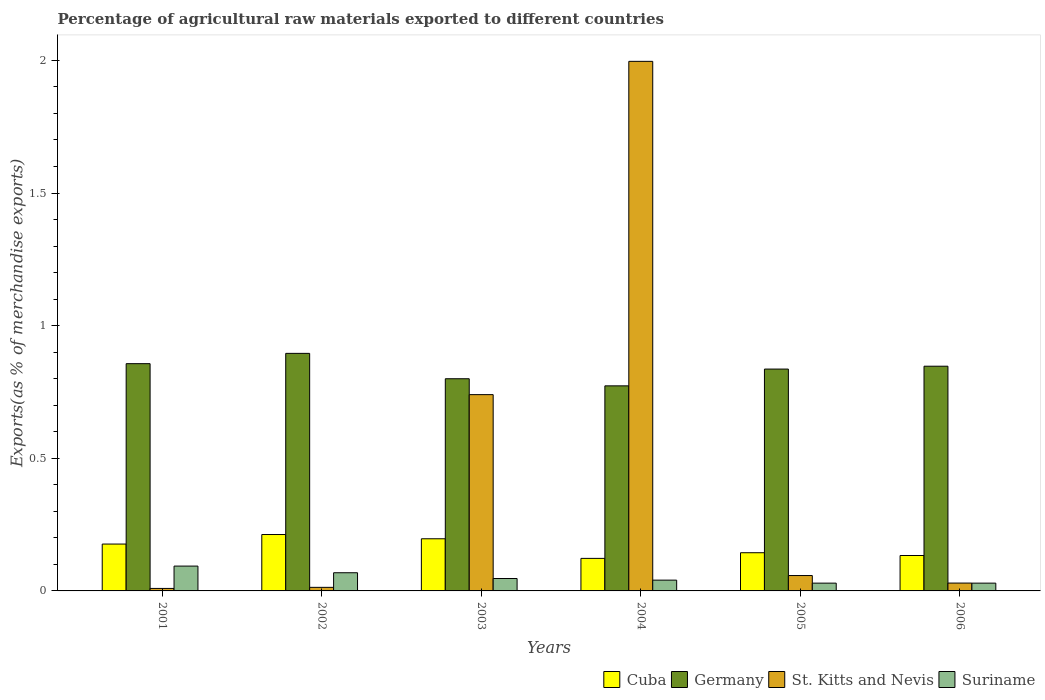How many different coloured bars are there?
Ensure brevity in your answer.  4. Are the number of bars per tick equal to the number of legend labels?
Provide a succinct answer. Yes. How many bars are there on the 5th tick from the left?
Make the answer very short. 4. How many bars are there on the 3rd tick from the right?
Offer a very short reply. 4. What is the label of the 4th group of bars from the left?
Provide a succinct answer. 2004. What is the percentage of exports to different countries in St. Kitts and Nevis in 2002?
Your answer should be compact. 0.01. Across all years, what is the maximum percentage of exports to different countries in Suriname?
Offer a very short reply. 0.09. Across all years, what is the minimum percentage of exports to different countries in Suriname?
Your answer should be compact. 0.03. In which year was the percentage of exports to different countries in Cuba minimum?
Make the answer very short. 2004. What is the total percentage of exports to different countries in St. Kitts and Nevis in the graph?
Offer a very short reply. 2.85. What is the difference between the percentage of exports to different countries in Germany in 2001 and that in 2004?
Provide a short and direct response. 0.08. What is the difference between the percentage of exports to different countries in Germany in 2003 and the percentage of exports to different countries in Suriname in 2001?
Your response must be concise. 0.71. What is the average percentage of exports to different countries in St. Kitts and Nevis per year?
Your answer should be compact. 0.47. In the year 2002, what is the difference between the percentage of exports to different countries in Germany and percentage of exports to different countries in Cuba?
Ensure brevity in your answer.  0.68. In how many years, is the percentage of exports to different countries in Suriname greater than 0.9 %?
Your response must be concise. 0. What is the ratio of the percentage of exports to different countries in Cuba in 2001 to that in 2003?
Ensure brevity in your answer.  0.9. What is the difference between the highest and the second highest percentage of exports to different countries in Suriname?
Your answer should be very brief. 0.03. What is the difference between the highest and the lowest percentage of exports to different countries in Cuba?
Make the answer very short. 0.09. Is the sum of the percentage of exports to different countries in Germany in 2003 and 2005 greater than the maximum percentage of exports to different countries in St. Kitts and Nevis across all years?
Keep it short and to the point. No. Is it the case that in every year, the sum of the percentage of exports to different countries in Germany and percentage of exports to different countries in Suriname is greater than the sum of percentage of exports to different countries in Cuba and percentage of exports to different countries in St. Kitts and Nevis?
Provide a short and direct response. Yes. What does the 4th bar from the left in 2004 represents?
Provide a succinct answer. Suriname. What does the 3rd bar from the right in 2005 represents?
Your response must be concise. Germany. Are the values on the major ticks of Y-axis written in scientific E-notation?
Your response must be concise. No. Does the graph contain any zero values?
Provide a succinct answer. No. Does the graph contain grids?
Offer a very short reply. No. Where does the legend appear in the graph?
Give a very brief answer. Bottom right. How are the legend labels stacked?
Give a very brief answer. Horizontal. What is the title of the graph?
Make the answer very short. Percentage of agricultural raw materials exported to different countries. Does "Tunisia" appear as one of the legend labels in the graph?
Keep it short and to the point. No. What is the label or title of the Y-axis?
Provide a succinct answer. Exports(as % of merchandise exports). What is the Exports(as % of merchandise exports) in Cuba in 2001?
Offer a very short reply. 0.18. What is the Exports(as % of merchandise exports) in Germany in 2001?
Provide a succinct answer. 0.86. What is the Exports(as % of merchandise exports) in St. Kitts and Nevis in 2001?
Your answer should be very brief. 0.01. What is the Exports(as % of merchandise exports) of Suriname in 2001?
Give a very brief answer. 0.09. What is the Exports(as % of merchandise exports) of Cuba in 2002?
Keep it short and to the point. 0.21. What is the Exports(as % of merchandise exports) of Germany in 2002?
Give a very brief answer. 0.9. What is the Exports(as % of merchandise exports) of St. Kitts and Nevis in 2002?
Make the answer very short. 0.01. What is the Exports(as % of merchandise exports) of Suriname in 2002?
Provide a short and direct response. 0.07. What is the Exports(as % of merchandise exports) of Cuba in 2003?
Your answer should be compact. 0.2. What is the Exports(as % of merchandise exports) of Germany in 2003?
Offer a terse response. 0.8. What is the Exports(as % of merchandise exports) in St. Kitts and Nevis in 2003?
Offer a very short reply. 0.74. What is the Exports(as % of merchandise exports) in Suriname in 2003?
Offer a terse response. 0.05. What is the Exports(as % of merchandise exports) in Cuba in 2004?
Offer a terse response. 0.12. What is the Exports(as % of merchandise exports) in Germany in 2004?
Your answer should be very brief. 0.77. What is the Exports(as % of merchandise exports) in St. Kitts and Nevis in 2004?
Give a very brief answer. 2. What is the Exports(as % of merchandise exports) of Suriname in 2004?
Your answer should be very brief. 0.04. What is the Exports(as % of merchandise exports) in Cuba in 2005?
Keep it short and to the point. 0.14. What is the Exports(as % of merchandise exports) in Germany in 2005?
Your response must be concise. 0.84. What is the Exports(as % of merchandise exports) of St. Kitts and Nevis in 2005?
Provide a short and direct response. 0.06. What is the Exports(as % of merchandise exports) in Suriname in 2005?
Ensure brevity in your answer.  0.03. What is the Exports(as % of merchandise exports) in Cuba in 2006?
Provide a short and direct response. 0.13. What is the Exports(as % of merchandise exports) of Germany in 2006?
Offer a terse response. 0.85. What is the Exports(as % of merchandise exports) in St. Kitts and Nevis in 2006?
Keep it short and to the point. 0.03. What is the Exports(as % of merchandise exports) of Suriname in 2006?
Offer a terse response. 0.03. Across all years, what is the maximum Exports(as % of merchandise exports) of Cuba?
Your response must be concise. 0.21. Across all years, what is the maximum Exports(as % of merchandise exports) in Germany?
Provide a short and direct response. 0.9. Across all years, what is the maximum Exports(as % of merchandise exports) of St. Kitts and Nevis?
Your answer should be compact. 2. Across all years, what is the maximum Exports(as % of merchandise exports) of Suriname?
Provide a short and direct response. 0.09. Across all years, what is the minimum Exports(as % of merchandise exports) of Cuba?
Make the answer very short. 0.12. Across all years, what is the minimum Exports(as % of merchandise exports) in Germany?
Make the answer very short. 0.77. Across all years, what is the minimum Exports(as % of merchandise exports) of St. Kitts and Nevis?
Ensure brevity in your answer.  0.01. Across all years, what is the minimum Exports(as % of merchandise exports) in Suriname?
Provide a short and direct response. 0.03. What is the total Exports(as % of merchandise exports) of Cuba in the graph?
Keep it short and to the point. 0.99. What is the total Exports(as % of merchandise exports) of Germany in the graph?
Give a very brief answer. 5.01. What is the total Exports(as % of merchandise exports) of St. Kitts and Nevis in the graph?
Your answer should be very brief. 2.85. What is the total Exports(as % of merchandise exports) of Suriname in the graph?
Provide a succinct answer. 0.31. What is the difference between the Exports(as % of merchandise exports) of Cuba in 2001 and that in 2002?
Provide a short and direct response. -0.04. What is the difference between the Exports(as % of merchandise exports) of Germany in 2001 and that in 2002?
Your answer should be compact. -0.04. What is the difference between the Exports(as % of merchandise exports) in St. Kitts and Nevis in 2001 and that in 2002?
Ensure brevity in your answer.  -0. What is the difference between the Exports(as % of merchandise exports) in Suriname in 2001 and that in 2002?
Provide a short and direct response. 0.03. What is the difference between the Exports(as % of merchandise exports) of Cuba in 2001 and that in 2003?
Give a very brief answer. -0.02. What is the difference between the Exports(as % of merchandise exports) in Germany in 2001 and that in 2003?
Provide a short and direct response. 0.06. What is the difference between the Exports(as % of merchandise exports) in St. Kitts and Nevis in 2001 and that in 2003?
Offer a terse response. -0.73. What is the difference between the Exports(as % of merchandise exports) in Suriname in 2001 and that in 2003?
Ensure brevity in your answer.  0.05. What is the difference between the Exports(as % of merchandise exports) in Cuba in 2001 and that in 2004?
Your response must be concise. 0.05. What is the difference between the Exports(as % of merchandise exports) of Germany in 2001 and that in 2004?
Give a very brief answer. 0.08. What is the difference between the Exports(as % of merchandise exports) of St. Kitts and Nevis in 2001 and that in 2004?
Offer a terse response. -1.99. What is the difference between the Exports(as % of merchandise exports) of Suriname in 2001 and that in 2004?
Ensure brevity in your answer.  0.05. What is the difference between the Exports(as % of merchandise exports) in Cuba in 2001 and that in 2005?
Your answer should be compact. 0.03. What is the difference between the Exports(as % of merchandise exports) of Germany in 2001 and that in 2005?
Your response must be concise. 0.02. What is the difference between the Exports(as % of merchandise exports) in St. Kitts and Nevis in 2001 and that in 2005?
Offer a very short reply. -0.05. What is the difference between the Exports(as % of merchandise exports) in Suriname in 2001 and that in 2005?
Your response must be concise. 0.06. What is the difference between the Exports(as % of merchandise exports) in Cuba in 2001 and that in 2006?
Give a very brief answer. 0.04. What is the difference between the Exports(as % of merchandise exports) in Germany in 2001 and that in 2006?
Provide a short and direct response. 0.01. What is the difference between the Exports(as % of merchandise exports) in St. Kitts and Nevis in 2001 and that in 2006?
Your answer should be very brief. -0.02. What is the difference between the Exports(as % of merchandise exports) in Suriname in 2001 and that in 2006?
Provide a succinct answer. 0.06. What is the difference between the Exports(as % of merchandise exports) of Cuba in 2002 and that in 2003?
Provide a succinct answer. 0.02. What is the difference between the Exports(as % of merchandise exports) in Germany in 2002 and that in 2003?
Ensure brevity in your answer.  0.1. What is the difference between the Exports(as % of merchandise exports) in St. Kitts and Nevis in 2002 and that in 2003?
Your answer should be very brief. -0.73. What is the difference between the Exports(as % of merchandise exports) of Suriname in 2002 and that in 2003?
Keep it short and to the point. 0.02. What is the difference between the Exports(as % of merchandise exports) of Cuba in 2002 and that in 2004?
Keep it short and to the point. 0.09. What is the difference between the Exports(as % of merchandise exports) of Germany in 2002 and that in 2004?
Keep it short and to the point. 0.12. What is the difference between the Exports(as % of merchandise exports) in St. Kitts and Nevis in 2002 and that in 2004?
Offer a very short reply. -1.98. What is the difference between the Exports(as % of merchandise exports) of Suriname in 2002 and that in 2004?
Your response must be concise. 0.03. What is the difference between the Exports(as % of merchandise exports) of Cuba in 2002 and that in 2005?
Ensure brevity in your answer.  0.07. What is the difference between the Exports(as % of merchandise exports) of Germany in 2002 and that in 2005?
Offer a very short reply. 0.06. What is the difference between the Exports(as % of merchandise exports) of St. Kitts and Nevis in 2002 and that in 2005?
Your answer should be very brief. -0.04. What is the difference between the Exports(as % of merchandise exports) of Suriname in 2002 and that in 2005?
Offer a very short reply. 0.04. What is the difference between the Exports(as % of merchandise exports) in Cuba in 2002 and that in 2006?
Offer a very short reply. 0.08. What is the difference between the Exports(as % of merchandise exports) of Germany in 2002 and that in 2006?
Make the answer very short. 0.05. What is the difference between the Exports(as % of merchandise exports) of St. Kitts and Nevis in 2002 and that in 2006?
Provide a short and direct response. -0.02. What is the difference between the Exports(as % of merchandise exports) of Suriname in 2002 and that in 2006?
Provide a short and direct response. 0.04. What is the difference between the Exports(as % of merchandise exports) in Cuba in 2003 and that in 2004?
Provide a short and direct response. 0.07. What is the difference between the Exports(as % of merchandise exports) in Germany in 2003 and that in 2004?
Give a very brief answer. 0.03. What is the difference between the Exports(as % of merchandise exports) in St. Kitts and Nevis in 2003 and that in 2004?
Give a very brief answer. -1.26. What is the difference between the Exports(as % of merchandise exports) in Suriname in 2003 and that in 2004?
Keep it short and to the point. 0.01. What is the difference between the Exports(as % of merchandise exports) in Cuba in 2003 and that in 2005?
Give a very brief answer. 0.05. What is the difference between the Exports(as % of merchandise exports) of Germany in 2003 and that in 2005?
Give a very brief answer. -0.04. What is the difference between the Exports(as % of merchandise exports) in St. Kitts and Nevis in 2003 and that in 2005?
Keep it short and to the point. 0.68. What is the difference between the Exports(as % of merchandise exports) of Suriname in 2003 and that in 2005?
Offer a terse response. 0.02. What is the difference between the Exports(as % of merchandise exports) in Cuba in 2003 and that in 2006?
Make the answer very short. 0.06. What is the difference between the Exports(as % of merchandise exports) in Germany in 2003 and that in 2006?
Your answer should be compact. -0.05. What is the difference between the Exports(as % of merchandise exports) of St. Kitts and Nevis in 2003 and that in 2006?
Provide a succinct answer. 0.71. What is the difference between the Exports(as % of merchandise exports) of Suriname in 2003 and that in 2006?
Offer a terse response. 0.02. What is the difference between the Exports(as % of merchandise exports) in Cuba in 2004 and that in 2005?
Your response must be concise. -0.02. What is the difference between the Exports(as % of merchandise exports) of Germany in 2004 and that in 2005?
Your response must be concise. -0.06. What is the difference between the Exports(as % of merchandise exports) of St. Kitts and Nevis in 2004 and that in 2005?
Offer a very short reply. 1.94. What is the difference between the Exports(as % of merchandise exports) in Suriname in 2004 and that in 2005?
Make the answer very short. 0.01. What is the difference between the Exports(as % of merchandise exports) in Cuba in 2004 and that in 2006?
Provide a short and direct response. -0.01. What is the difference between the Exports(as % of merchandise exports) of Germany in 2004 and that in 2006?
Ensure brevity in your answer.  -0.07. What is the difference between the Exports(as % of merchandise exports) in St. Kitts and Nevis in 2004 and that in 2006?
Make the answer very short. 1.97. What is the difference between the Exports(as % of merchandise exports) of Suriname in 2004 and that in 2006?
Give a very brief answer. 0.01. What is the difference between the Exports(as % of merchandise exports) in Cuba in 2005 and that in 2006?
Your answer should be very brief. 0.01. What is the difference between the Exports(as % of merchandise exports) of Germany in 2005 and that in 2006?
Your response must be concise. -0.01. What is the difference between the Exports(as % of merchandise exports) in St. Kitts and Nevis in 2005 and that in 2006?
Make the answer very short. 0.03. What is the difference between the Exports(as % of merchandise exports) of Suriname in 2005 and that in 2006?
Your answer should be very brief. 0. What is the difference between the Exports(as % of merchandise exports) in Cuba in 2001 and the Exports(as % of merchandise exports) in Germany in 2002?
Provide a succinct answer. -0.72. What is the difference between the Exports(as % of merchandise exports) of Cuba in 2001 and the Exports(as % of merchandise exports) of St. Kitts and Nevis in 2002?
Give a very brief answer. 0.16. What is the difference between the Exports(as % of merchandise exports) of Cuba in 2001 and the Exports(as % of merchandise exports) of Suriname in 2002?
Provide a succinct answer. 0.11. What is the difference between the Exports(as % of merchandise exports) of Germany in 2001 and the Exports(as % of merchandise exports) of St. Kitts and Nevis in 2002?
Your answer should be compact. 0.84. What is the difference between the Exports(as % of merchandise exports) in Germany in 2001 and the Exports(as % of merchandise exports) in Suriname in 2002?
Offer a very short reply. 0.79. What is the difference between the Exports(as % of merchandise exports) in St. Kitts and Nevis in 2001 and the Exports(as % of merchandise exports) in Suriname in 2002?
Your answer should be compact. -0.06. What is the difference between the Exports(as % of merchandise exports) in Cuba in 2001 and the Exports(as % of merchandise exports) in Germany in 2003?
Give a very brief answer. -0.62. What is the difference between the Exports(as % of merchandise exports) in Cuba in 2001 and the Exports(as % of merchandise exports) in St. Kitts and Nevis in 2003?
Provide a succinct answer. -0.56. What is the difference between the Exports(as % of merchandise exports) in Cuba in 2001 and the Exports(as % of merchandise exports) in Suriname in 2003?
Provide a succinct answer. 0.13. What is the difference between the Exports(as % of merchandise exports) in Germany in 2001 and the Exports(as % of merchandise exports) in St. Kitts and Nevis in 2003?
Your answer should be compact. 0.12. What is the difference between the Exports(as % of merchandise exports) in Germany in 2001 and the Exports(as % of merchandise exports) in Suriname in 2003?
Your answer should be compact. 0.81. What is the difference between the Exports(as % of merchandise exports) of St. Kitts and Nevis in 2001 and the Exports(as % of merchandise exports) of Suriname in 2003?
Offer a terse response. -0.04. What is the difference between the Exports(as % of merchandise exports) in Cuba in 2001 and the Exports(as % of merchandise exports) in Germany in 2004?
Your answer should be very brief. -0.6. What is the difference between the Exports(as % of merchandise exports) in Cuba in 2001 and the Exports(as % of merchandise exports) in St. Kitts and Nevis in 2004?
Your answer should be compact. -1.82. What is the difference between the Exports(as % of merchandise exports) of Cuba in 2001 and the Exports(as % of merchandise exports) of Suriname in 2004?
Your answer should be compact. 0.14. What is the difference between the Exports(as % of merchandise exports) of Germany in 2001 and the Exports(as % of merchandise exports) of St. Kitts and Nevis in 2004?
Make the answer very short. -1.14. What is the difference between the Exports(as % of merchandise exports) of Germany in 2001 and the Exports(as % of merchandise exports) of Suriname in 2004?
Your answer should be compact. 0.82. What is the difference between the Exports(as % of merchandise exports) in St. Kitts and Nevis in 2001 and the Exports(as % of merchandise exports) in Suriname in 2004?
Provide a short and direct response. -0.03. What is the difference between the Exports(as % of merchandise exports) in Cuba in 2001 and the Exports(as % of merchandise exports) in Germany in 2005?
Provide a short and direct response. -0.66. What is the difference between the Exports(as % of merchandise exports) of Cuba in 2001 and the Exports(as % of merchandise exports) of St. Kitts and Nevis in 2005?
Keep it short and to the point. 0.12. What is the difference between the Exports(as % of merchandise exports) in Cuba in 2001 and the Exports(as % of merchandise exports) in Suriname in 2005?
Offer a very short reply. 0.15. What is the difference between the Exports(as % of merchandise exports) in Germany in 2001 and the Exports(as % of merchandise exports) in St. Kitts and Nevis in 2005?
Offer a very short reply. 0.8. What is the difference between the Exports(as % of merchandise exports) of Germany in 2001 and the Exports(as % of merchandise exports) of Suriname in 2005?
Your response must be concise. 0.83. What is the difference between the Exports(as % of merchandise exports) of St. Kitts and Nevis in 2001 and the Exports(as % of merchandise exports) of Suriname in 2005?
Provide a short and direct response. -0.02. What is the difference between the Exports(as % of merchandise exports) in Cuba in 2001 and the Exports(as % of merchandise exports) in Germany in 2006?
Offer a terse response. -0.67. What is the difference between the Exports(as % of merchandise exports) of Cuba in 2001 and the Exports(as % of merchandise exports) of St. Kitts and Nevis in 2006?
Your answer should be compact. 0.15. What is the difference between the Exports(as % of merchandise exports) of Cuba in 2001 and the Exports(as % of merchandise exports) of Suriname in 2006?
Your response must be concise. 0.15. What is the difference between the Exports(as % of merchandise exports) in Germany in 2001 and the Exports(as % of merchandise exports) in St. Kitts and Nevis in 2006?
Offer a very short reply. 0.83. What is the difference between the Exports(as % of merchandise exports) in Germany in 2001 and the Exports(as % of merchandise exports) in Suriname in 2006?
Give a very brief answer. 0.83. What is the difference between the Exports(as % of merchandise exports) of St. Kitts and Nevis in 2001 and the Exports(as % of merchandise exports) of Suriname in 2006?
Keep it short and to the point. -0.02. What is the difference between the Exports(as % of merchandise exports) of Cuba in 2002 and the Exports(as % of merchandise exports) of Germany in 2003?
Offer a terse response. -0.59. What is the difference between the Exports(as % of merchandise exports) of Cuba in 2002 and the Exports(as % of merchandise exports) of St. Kitts and Nevis in 2003?
Provide a succinct answer. -0.53. What is the difference between the Exports(as % of merchandise exports) of Cuba in 2002 and the Exports(as % of merchandise exports) of Suriname in 2003?
Keep it short and to the point. 0.17. What is the difference between the Exports(as % of merchandise exports) in Germany in 2002 and the Exports(as % of merchandise exports) in St. Kitts and Nevis in 2003?
Offer a terse response. 0.16. What is the difference between the Exports(as % of merchandise exports) in Germany in 2002 and the Exports(as % of merchandise exports) in Suriname in 2003?
Keep it short and to the point. 0.85. What is the difference between the Exports(as % of merchandise exports) of St. Kitts and Nevis in 2002 and the Exports(as % of merchandise exports) of Suriname in 2003?
Your answer should be compact. -0.03. What is the difference between the Exports(as % of merchandise exports) in Cuba in 2002 and the Exports(as % of merchandise exports) in Germany in 2004?
Offer a very short reply. -0.56. What is the difference between the Exports(as % of merchandise exports) in Cuba in 2002 and the Exports(as % of merchandise exports) in St. Kitts and Nevis in 2004?
Ensure brevity in your answer.  -1.78. What is the difference between the Exports(as % of merchandise exports) in Cuba in 2002 and the Exports(as % of merchandise exports) in Suriname in 2004?
Provide a succinct answer. 0.17. What is the difference between the Exports(as % of merchandise exports) of Germany in 2002 and the Exports(as % of merchandise exports) of St. Kitts and Nevis in 2004?
Provide a short and direct response. -1.1. What is the difference between the Exports(as % of merchandise exports) of Germany in 2002 and the Exports(as % of merchandise exports) of Suriname in 2004?
Offer a terse response. 0.85. What is the difference between the Exports(as % of merchandise exports) in St. Kitts and Nevis in 2002 and the Exports(as % of merchandise exports) in Suriname in 2004?
Offer a terse response. -0.03. What is the difference between the Exports(as % of merchandise exports) in Cuba in 2002 and the Exports(as % of merchandise exports) in Germany in 2005?
Your answer should be compact. -0.62. What is the difference between the Exports(as % of merchandise exports) in Cuba in 2002 and the Exports(as % of merchandise exports) in St. Kitts and Nevis in 2005?
Offer a terse response. 0.15. What is the difference between the Exports(as % of merchandise exports) of Cuba in 2002 and the Exports(as % of merchandise exports) of Suriname in 2005?
Ensure brevity in your answer.  0.18. What is the difference between the Exports(as % of merchandise exports) in Germany in 2002 and the Exports(as % of merchandise exports) in St. Kitts and Nevis in 2005?
Your response must be concise. 0.84. What is the difference between the Exports(as % of merchandise exports) of Germany in 2002 and the Exports(as % of merchandise exports) of Suriname in 2005?
Your answer should be compact. 0.87. What is the difference between the Exports(as % of merchandise exports) of St. Kitts and Nevis in 2002 and the Exports(as % of merchandise exports) of Suriname in 2005?
Make the answer very short. -0.02. What is the difference between the Exports(as % of merchandise exports) of Cuba in 2002 and the Exports(as % of merchandise exports) of Germany in 2006?
Offer a very short reply. -0.63. What is the difference between the Exports(as % of merchandise exports) of Cuba in 2002 and the Exports(as % of merchandise exports) of St. Kitts and Nevis in 2006?
Provide a succinct answer. 0.18. What is the difference between the Exports(as % of merchandise exports) in Cuba in 2002 and the Exports(as % of merchandise exports) in Suriname in 2006?
Provide a short and direct response. 0.18. What is the difference between the Exports(as % of merchandise exports) of Germany in 2002 and the Exports(as % of merchandise exports) of St. Kitts and Nevis in 2006?
Keep it short and to the point. 0.87. What is the difference between the Exports(as % of merchandise exports) of Germany in 2002 and the Exports(as % of merchandise exports) of Suriname in 2006?
Provide a short and direct response. 0.87. What is the difference between the Exports(as % of merchandise exports) in St. Kitts and Nevis in 2002 and the Exports(as % of merchandise exports) in Suriname in 2006?
Offer a terse response. -0.02. What is the difference between the Exports(as % of merchandise exports) of Cuba in 2003 and the Exports(as % of merchandise exports) of Germany in 2004?
Your answer should be compact. -0.58. What is the difference between the Exports(as % of merchandise exports) of Cuba in 2003 and the Exports(as % of merchandise exports) of St. Kitts and Nevis in 2004?
Provide a short and direct response. -1.8. What is the difference between the Exports(as % of merchandise exports) of Cuba in 2003 and the Exports(as % of merchandise exports) of Suriname in 2004?
Your response must be concise. 0.16. What is the difference between the Exports(as % of merchandise exports) in Germany in 2003 and the Exports(as % of merchandise exports) in St. Kitts and Nevis in 2004?
Offer a very short reply. -1.2. What is the difference between the Exports(as % of merchandise exports) of Germany in 2003 and the Exports(as % of merchandise exports) of Suriname in 2004?
Your answer should be compact. 0.76. What is the difference between the Exports(as % of merchandise exports) of St. Kitts and Nevis in 2003 and the Exports(as % of merchandise exports) of Suriname in 2004?
Your answer should be compact. 0.7. What is the difference between the Exports(as % of merchandise exports) of Cuba in 2003 and the Exports(as % of merchandise exports) of Germany in 2005?
Provide a short and direct response. -0.64. What is the difference between the Exports(as % of merchandise exports) of Cuba in 2003 and the Exports(as % of merchandise exports) of St. Kitts and Nevis in 2005?
Your response must be concise. 0.14. What is the difference between the Exports(as % of merchandise exports) of Cuba in 2003 and the Exports(as % of merchandise exports) of Suriname in 2005?
Make the answer very short. 0.17. What is the difference between the Exports(as % of merchandise exports) in Germany in 2003 and the Exports(as % of merchandise exports) in St. Kitts and Nevis in 2005?
Provide a short and direct response. 0.74. What is the difference between the Exports(as % of merchandise exports) in Germany in 2003 and the Exports(as % of merchandise exports) in Suriname in 2005?
Keep it short and to the point. 0.77. What is the difference between the Exports(as % of merchandise exports) of St. Kitts and Nevis in 2003 and the Exports(as % of merchandise exports) of Suriname in 2005?
Your response must be concise. 0.71. What is the difference between the Exports(as % of merchandise exports) in Cuba in 2003 and the Exports(as % of merchandise exports) in Germany in 2006?
Ensure brevity in your answer.  -0.65. What is the difference between the Exports(as % of merchandise exports) in Cuba in 2003 and the Exports(as % of merchandise exports) in St. Kitts and Nevis in 2006?
Ensure brevity in your answer.  0.17. What is the difference between the Exports(as % of merchandise exports) of Cuba in 2003 and the Exports(as % of merchandise exports) of Suriname in 2006?
Your response must be concise. 0.17. What is the difference between the Exports(as % of merchandise exports) of Germany in 2003 and the Exports(as % of merchandise exports) of St. Kitts and Nevis in 2006?
Offer a terse response. 0.77. What is the difference between the Exports(as % of merchandise exports) in Germany in 2003 and the Exports(as % of merchandise exports) in Suriname in 2006?
Your response must be concise. 0.77. What is the difference between the Exports(as % of merchandise exports) in St. Kitts and Nevis in 2003 and the Exports(as % of merchandise exports) in Suriname in 2006?
Offer a very short reply. 0.71. What is the difference between the Exports(as % of merchandise exports) of Cuba in 2004 and the Exports(as % of merchandise exports) of Germany in 2005?
Offer a very short reply. -0.71. What is the difference between the Exports(as % of merchandise exports) of Cuba in 2004 and the Exports(as % of merchandise exports) of St. Kitts and Nevis in 2005?
Your response must be concise. 0.06. What is the difference between the Exports(as % of merchandise exports) in Cuba in 2004 and the Exports(as % of merchandise exports) in Suriname in 2005?
Give a very brief answer. 0.09. What is the difference between the Exports(as % of merchandise exports) of Germany in 2004 and the Exports(as % of merchandise exports) of St. Kitts and Nevis in 2005?
Keep it short and to the point. 0.72. What is the difference between the Exports(as % of merchandise exports) in Germany in 2004 and the Exports(as % of merchandise exports) in Suriname in 2005?
Offer a very short reply. 0.74. What is the difference between the Exports(as % of merchandise exports) of St. Kitts and Nevis in 2004 and the Exports(as % of merchandise exports) of Suriname in 2005?
Offer a very short reply. 1.97. What is the difference between the Exports(as % of merchandise exports) of Cuba in 2004 and the Exports(as % of merchandise exports) of Germany in 2006?
Offer a terse response. -0.72. What is the difference between the Exports(as % of merchandise exports) in Cuba in 2004 and the Exports(as % of merchandise exports) in St. Kitts and Nevis in 2006?
Provide a succinct answer. 0.09. What is the difference between the Exports(as % of merchandise exports) in Cuba in 2004 and the Exports(as % of merchandise exports) in Suriname in 2006?
Ensure brevity in your answer.  0.09. What is the difference between the Exports(as % of merchandise exports) in Germany in 2004 and the Exports(as % of merchandise exports) in St. Kitts and Nevis in 2006?
Offer a terse response. 0.74. What is the difference between the Exports(as % of merchandise exports) in Germany in 2004 and the Exports(as % of merchandise exports) in Suriname in 2006?
Give a very brief answer. 0.74. What is the difference between the Exports(as % of merchandise exports) of St. Kitts and Nevis in 2004 and the Exports(as % of merchandise exports) of Suriname in 2006?
Your response must be concise. 1.97. What is the difference between the Exports(as % of merchandise exports) in Cuba in 2005 and the Exports(as % of merchandise exports) in Germany in 2006?
Your answer should be compact. -0.7. What is the difference between the Exports(as % of merchandise exports) in Cuba in 2005 and the Exports(as % of merchandise exports) in St. Kitts and Nevis in 2006?
Make the answer very short. 0.11. What is the difference between the Exports(as % of merchandise exports) in Cuba in 2005 and the Exports(as % of merchandise exports) in Suriname in 2006?
Your answer should be compact. 0.11. What is the difference between the Exports(as % of merchandise exports) of Germany in 2005 and the Exports(as % of merchandise exports) of St. Kitts and Nevis in 2006?
Keep it short and to the point. 0.81. What is the difference between the Exports(as % of merchandise exports) of Germany in 2005 and the Exports(as % of merchandise exports) of Suriname in 2006?
Make the answer very short. 0.81. What is the difference between the Exports(as % of merchandise exports) in St. Kitts and Nevis in 2005 and the Exports(as % of merchandise exports) in Suriname in 2006?
Offer a very short reply. 0.03. What is the average Exports(as % of merchandise exports) in Cuba per year?
Your response must be concise. 0.16. What is the average Exports(as % of merchandise exports) of Germany per year?
Give a very brief answer. 0.83. What is the average Exports(as % of merchandise exports) of St. Kitts and Nevis per year?
Give a very brief answer. 0.47. What is the average Exports(as % of merchandise exports) of Suriname per year?
Offer a terse response. 0.05. In the year 2001, what is the difference between the Exports(as % of merchandise exports) in Cuba and Exports(as % of merchandise exports) in Germany?
Your answer should be compact. -0.68. In the year 2001, what is the difference between the Exports(as % of merchandise exports) in Cuba and Exports(as % of merchandise exports) in St. Kitts and Nevis?
Offer a very short reply. 0.17. In the year 2001, what is the difference between the Exports(as % of merchandise exports) of Cuba and Exports(as % of merchandise exports) of Suriname?
Make the answer very short. 0.08. In the year 2001, what is the difference between the Exports(as % of merchandise exports) of Germany and Exports(as % of merchandise exports) of St. Kitts and Nevis?
Offer a very short reply. 0.85. In the year 2001, what is the difference between the Exports(as % of merchandise exports) of Germany and Exports(as % of merchandise exports) of Suriname?
Ensure brevity in your answer.  0.76. In the year 2001, what is the difference between the Exports(as % of merchandise exports) of St. Kitts and Nevis and Exports(as % of merchandise exports) of Suriname?
Your answer should be compact. -0.08. In the year 2002, what is the difference between the Exports(as % of merchandise exports) in Cuba and Exports(as % of merchandise exports) in Germany?
Provide a short and direct response. -0.68. In the year 2002, what is the difference between the Exports(as % of merchandise exports) of Cuba and Exports(as % of merchandise exports) of St. Kitts and Nevis?
Offer a terse response. 0.2. In the year 2002, what is the difference between the Exports(as % of merchandise exports) in Cuba and Exports(as % of merchandise exports) in Suriname?
Keep it short and to the point. 0.14. In the year 2002, what is the difference between the Exports(as % of merchandise exports) in Germany and Exports(as % of merchandise exports) in St. Kitts and Nevis?
Ensure brevity in your answer.  0.88. In the year 2002, what is the difference between the Exports(as % of merchandise exports) in Germany and Exports(as % of merchandise exports) in Suriname?
Your answer should be very brief. 0.83. In the year 2002, what is the difference between the Exports(as % of merchandise exports) in St. Kitts and Nevis and Exports(as % of merchandise exports) in Suriname?
Provide a succinct answer. -0.06. In the year 2003, what is the difference between the Exports(as % of merchandise exports) of Cuba and Exports(as % of merchandise exports) of Germany?
Ensure brevity in your answer.  -0.6. In the year 2003, what is the difference between the Exports(as % of merchandise exports) in Cuba and Exports(as % of merchandise exports) in St. Kitts and Nevis?
Keep it short and to the point. -0.54. In the year 2003, what is the difference between the Exports(as % of merchandise exports) in Cuba and Exports(as % of merchandise exports) in Suriname?
Your answer should be very brief. 0.15. In the year 2003, what is the difference between the Exports(as % of merchandise exports) of Germany and Exports(as % of merchandise exports) of St. Kitts and Nevis?
Provide a short and direct response. 0.06. In the year 2003, what is the difference between the Exports(as % of merchandise exports) in Germany and Exports(as % of merchandise exports) in Suriname?
Your answer should be compact. 0.75. In the year 2003, what is the difference between the Exports(as % of merchandise exports) in St. Kitts and Nevis and Exports(as % of merchandise exports) in Suriname?
Your response must be concise. 0.69. In the year 2004, what is the difference between the Exports(as % of merchandise exports) in Cuba and Exports(as % of merchandise exports) in Germany?
Ensure brevity in your answer.  -0.65. In the year 2004, what is the difference between the Exports(as % of merchandise exports) of Cuba and Exports(as % of merchandise exports) of St. Kitts and Nevis?
Provide a succinct answer. -1.87. In the year 2004, what is the difference between the Exports(as % of merchandise exports) of Cuba and Exports(as % of merchandise exports) of Suriname?
Make the answer very short. 0.08. In the year 2004, what is the difference between the Exports(as % of merchandise exports) in Germany and Exports(as % of merchandise exports) in St. Kitts and Nevis?
Ensure brevity in your answer.  -1.22. In the year 2004, what is the difference between the Exports(as % of merchandise exports) of Germany and Exports(as % of merchandise exports) of Suriname?
Provide a succinct answer. 0.73. In the year 2004, what is the difference between the Exports(as % of merchandise exports) in St. Kitts and Nevis and Exports(as % of merchandise exports) in Suriname?
Keep it short and to the point. 1.96. In the year 2005, what is the difference between the Exports(as % of merchandise exports) in Cuba and Exports(as % of merchandise exports) in Germany?
Your answer should be compact. -0.69. In the year 2005, what is the difference between the Exports(as % of merchandise exports) of Cuba and Exports(as % of merchandise exports) of St. Kitts and Nevis?
Ensure brevity in your answer.  0.09. In the year 2005, what is the difference between the Exports(as % of merchandise exports) in Cuba and Exports(as % of merchandise exports) in Suriname?
Make the answer very short. 0.11. In the year 2005, what is the difference between the Exports(as % of merchandise exports) in Germany and Exports(as % of merchandise exports) in St. Kitts and Nevis?
Keep it short and to the point. 0.78. In the year 2005, what is the difference between the Exports(as % of merchandise exports) in Germany and Exports(as % of merchandise exports) in Suriname?
Offer a terse response. 0.81. In the year 2005, what is the difference between the Exports(as % of merchandise exports) in St. Kitts and Nevis and Exports(as % of merchandise exports) in Suriname?
Your answer should be compact. 0.03. In the year 2006, what is the difference between the Exports(as % of merchandise exports) in Cuba and Exports(as % of merchandise exports) in Germany?
Keep it short and to the point. -0.71. In the year 2006, what is the difference between the Exports(as % of merchandise exports) in Cuba and Exports(as % of merchandise exports) in St. Kitts and Nevis?
Ensure brevity in your answer.  0.1. In the year 2006, what is the difference between the Exports(as % of merchandise exports) of Cuba and Exports(as % of merchandise exports) of Suriname?
Offer a very short reply. 0.1. In the year 2006, what is the difference between the Exports(as % of merchandise exports) in Germany and Exports(as % of merchandise exports) in St. Kitts and Nevis?
Offer a very short reply. 0.82. In the year 2006, what is the difference between the Exports(as % of merchandise exports) of Germany and Exports(as % of merchandise exports) of Suriname?
Provide a short and direct response. 0.82. What is the ratio of the Exports(as % of merchandise exports) of Cuba in 2001 to that in 2002?
Your answer should be very brief. 0.83. What is the ratio of the Exports(as % of merchandise exports) in Germany in 2001 to that in 2002?
Offer a very short reply. 0.96. What is the ratio of the Exports(as % of merchandise exports) in St. Kitts and Nevis in 2001 to that in 2002?
Ensure brevity in your answer.  0.7. What is the ratio of the Exports(as % of merchandise exports) of Suriname in 2001 to that in 2002?
Provide a short and direct response. 1.37. What is the ratio of the Exports(as % of merchandise exports) of Cuba in 2001 to that in 2003?
Give a very brief answer. 0.9. What is the ratio of the Exports(as % of merchandise exports) in Germany in 2001 to that in 2003?
Your answer should be very brief. 1.07. What is the ratio of the Exports(as % of merchandise exports) of St. Kitts and Nevis in 2001 to that in 2003?
Offer a terse response. 0.01. What is the ratio of the Exports(as % of merchandise exports) in Suriname in 2001 to that in 2003?
Give a very brief answer. 2. What is the ratio of the Exports(as % of merchandise exports) in Cuba in 2001 to that in 2004?
Give a very brief answer. 1.44. What is the ratio of the Exports(as % of merchandise exports) of Germany in 2001 to that in 2004?
Offer a very short reply. 1.11. What is the ratio of the Exports(as % of merchandise exports) in St. Kitts and Nevis in 2001 to that in 2004?
Offer a very short reply. 0. What is the ratio of the Exports(as % of merchandise exports) in Suriname in 2001 to that in 2004?
Ensure brevity in your answer.  2.3. What is the ratio of the Exports(as % of merchandise exports) in Cuba in 2001 to that in 2005?
Provide a short and direct response. 1.23. What is the ratio of the Exports(as % of merchandise exports) in Germany in 2001 to that in 2005?
Your answer should be compact. 1.02. What is the ratio of the Exports(as % of merchandise exports) of St. Kitts and Nevis in 2001 to that in 2005?
Offer a very short reply. 0.16. What is the ratio of the Exports(as % of merchandise exports) in Suriname in 2001 to that in 2005?
Your answer should be compact. 3.19. What is the ratio of the Exports(as % of merchandise exports) of Cuba in 2001 to that in 2006?
Provide a succinct answer. 1.32. What is the ratio of the Exports(as % of merchandise exports) of Germany in 2001 to that in 2006?
Provide a succinct answer. 1.01. What is the ratio of the Exports(as % of merchandise exports) of St. Kitts and Nevis in 2001 to that in 2006?
Give a very brief answer. 0.32. What is the ratio of the Exports(as % of merchandise exports) of Suriname in 2001 to that in 2006?
Make the answer very short. 3.19. What is the ratio of the Exports(as % of merchandise exports) of Cuba in 2002 to that in 2003?
Make the answer very short. 1.08. What is the ratio of the Exports(as % of merchandise exports) in Germany in 2002 to that in 2003?
Make the answer very short. 1.12. What is the ratio of the Exports(as % of merchandise exports) in St. Kitts and Nevis in 2002 to that in 2003?
Provide a succinct answer. 0.02. What is the ratio of the Exports(as % of merchandise exports) in Suriname in 2002 to that in 2003?
Ensure brevity in your answer.  1.46. What is the ratio of the Exports(as % of merchandise exports) of Cuba in 2002 to that in 2004?
Your answer should be very brief. 1.73. What is the ratio of the Exports(as % of merchandise exports) in Germany in 2002 to that in 2004?
Provide a short and direct response. 1.16. What is the ratio of the Exports(as % of merchandise exports) in St. Kitts and Nevis in 2002 to that in 2004?
Offer a very short reply. 0.01. What is the ratio of the Exports(as % of merchandise exports) in Suriname in 2002 to that in 2004?
Offer a very short reply. 1.68. What is the ratio of the Exports(as % of merchandise exports) in Cuba in 2002 to that in 2005?
Offer a very short reply. 1.48. What is the ratio of the Exports(as % of merchandise exports) in Germany in 2002 to that in 2005?
Ensure brevity in your answer.  1.07. What is the ratio of the Exports(as % of merchandise exports) in St. Kitts and Nevis in 2002 to that in 2005?
Your response must be concise. 0.23. What is the ratio of the Exports(as % of merchandise exports) in Suriname in 2002 to that in 2005?
Offer a very short reply. 2.33. What is the ratio of the Exports(as % of merchandise exports) in Cuba in 2002 to that in 2006?
Your answer should be very brief. 1.59. What is the ratio of the Exports(as % of merchandise exports) of Germany in 2002 to that in 2006?
Provide a succinct answer. 1.06. What is the ratio of the Exports(as % of merchandise exports) of St. Kitts and Nevis in 2002 to that in 2006?
Keep it short and to the point. 0.45. What is the ratio of the Exports(as % of merchandise exports) in Suriname in 2002 to that in 2006?
Your answer should be compact. 2.34. What is the ratio of the Exports(as % of merchandise exports) of Cuba in 2003 to that in 2004?
Provide a succinct answer. 1.6. What is the ratio of the Exports(as % of merchandise exports) in Germany in 2003 to that in 2004?
Your response must be concise. 1.03. What is the ratio of the Exports(as % of merchandise exports) in St. Kitts and Nevis in 2003 to that in 2004?
Provide a succinct answer. 0.37. What is the ratio of the Exports(as % of merchandise exports) of Suriname in 2003 to that in 2004?
Keep it short and to the point. 1.15. What is the ratio of the Exports(as % of merchandise exports) of Cuba in 2003 to that in 2005?
Provide a short and direct response. 1.37. What is the ratio of the Exports(as % of merchandise exports) in Germany in 2003 to that in 2005?
Ensure brevity in your answer.  0.96. What is the ratio of the Exports(as % of merchandise exports) of St. Kitts and Nevis in 2003 to that in 2005?
Keep it short and to the point. 12.76. What is the ratio of the Exports(as % of merchandise exports) of Suriname in 2003 to that in 2005?
Make the answer very short. 1.59. What is the ratio of the Exports(as % of merchandise exports) in Cuba in 2003 to that in 2006?
Your response must be concise. 1.47. What is the ratio of the Exports(as % of merchandise exports) in Germany in 2003 to that in 2006?
Ensure brevity in your answer.  0.94. What is the ratio of the Exports(as % of merchandise exports) of St. Kitts and Nevis in 2003 to that in 2006?
Make the answer very short. 24.98. What is the ratio of the Exports(as % of merchandise exports) of Suriname in 2003 to that in 2006?
Provide a succinct answer. 1.59. What is the ratio of the Exports(as % of merchandise exports) in Cuba in 2004 to that in 2005?
Offer a terse response. 0.85. What is the ratio of the Exports(as % of merchandise exports) of Germany in 2004 to that in 2005?
Provide a succinct answer. 0.92. What is the ratio of the Exports(as % of merchandise exports) of St. Kitts and Nevis in 2004 to that in 2005?
Make the answer very short. 34.43. What is the ratio of the Exports(as % of merchandise exports) of Suriname in 2004 to that in 2005?
Your answer should be very brief. 1.39. What is the ratio of the Exports(as % of merchandise exports) in Cuba in 2004 to that in 2006?
Provide a short and direct response. 0.92. What is the ratio of the Exports(as % of merchandise exports) in Germany in 2004 to that in 2006?
Provide a succinct answer. 0.91. What is the ratio of the Exports(as % of merchandise exports) of St. Kitts and Nevis in 2004 to that in 2006?
Ensure brevity in your answer.  67.39. What is the ratio of the Exports(as % of merchandise exports) in Suriname in 2004 to that in 2006?
Provide a short and direct response. 1.39. What is the ratio of the Exports(as % of merchandise exports) in Cuba in 2005 to that in 2006?
Provide a succinct answer. 1.08. What is the ratio of the Exports(as % of merchandise exports) in Germany in 2005 to that in 2006?
Your answer should be compact. 0.99. What is the ratio of the Exports(as % of merchandise exports) in St. Kitts and Nevis in 2005 to that in 2006?
Your answer should be compact. 1.96. What is the ratio of the Exports(as % of merchandise exports) of Suriname in 2005 to that in 2006?
Ensure brevity in your answer.  1. What is the difference between the highest and the second highest Exports(as % of merchandise exports) of Cuba?
Provide a short and direct response. 0.02. What is the difference between the highest and the second highest Exports(as % of merchandise exports) of Germany?
Provide a succinct answer. 0.04. What is the difference between the highest and the second highest Exports(as % of merchandise exports) in St. Kitts and Nevis?
Your answer should be very brief. 1.26. What is the difference between the highest and the second highest Exports(as % of merchandise exports) of Suriname?
Give a very brief answer. 0.03. What is the difference between the highest and the lowest Exports(as % of merchandise exports) of Cuba?
Offer a very short reply. 0.09. What is the difference between the highest and the lowest Exports(as % of merchandise exports) of Germany?
Offer a terse response. 0.12. What is the difference between the highest and the lowest Exports(as % of merchandise exports) in St. Kitts and Nevis?
Make the answer very short. 1.99. What is the difference between the highest and the lowest Exports(as % of merchandise exports) of Suriname?
Offer a very short reply. 0.06. 